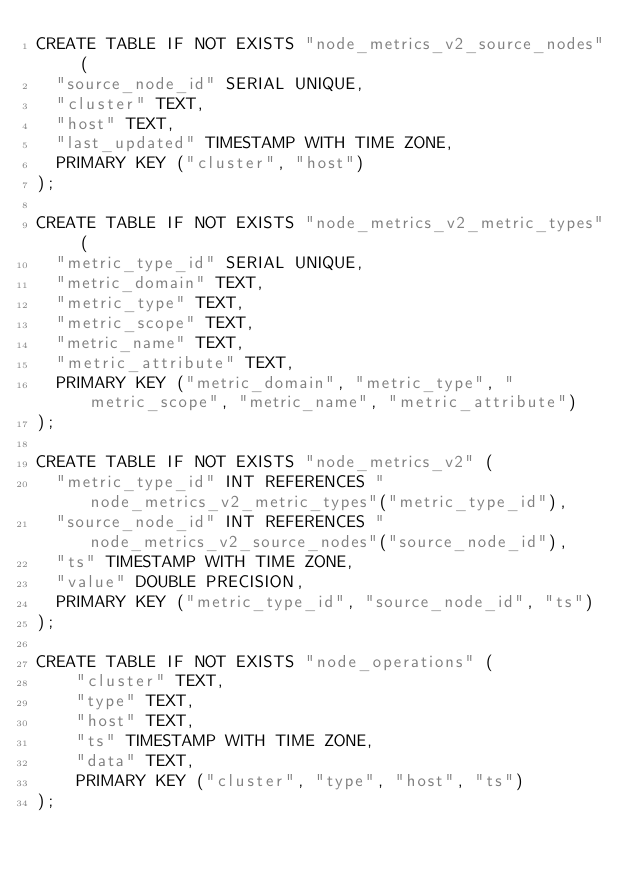Convert code to text. <code><loc_0><loc_0><loc_500><loc_500><_SQL_>CREATE TABLE IF NOT EXISTS "node_metrics_v2_source_nodes" (
  "source_node_id" SERIAL UNIQUE,
  "cluster" TEXT,
  "host" TEXT,
  "last_updated" TIMESTAMP WITH TIME ZONE,
  PRIMARY KEY ("cluster", "host")
);

CREATE TABLE IF NOT EXISTS "node_metrics_v2_metric_types" (
  "metric_type_id" SERIAL UNIQUE,
  "metric_domain" TEXT,
  "metric_type" TEXT,
  "metric_scope" TEXT,
  "metric_name" TEXT,
  "metric_attribute" TEXT,
  PRIMARY KEY ("metric_domain", "metric_type", "metric_scope", "metric_name", "metric_attribute")
);

CREATE TABLE IF NOT EXISTS "node_metrics_v2" (
  "metric_type_id" INT REFERENCES "node_metrics_v2_metric_types"("metric_type_id"),
  "source_node_id" INT REFERENCES "node_metrics_v2_source_nodes"("source_node_id"),
  "ts" TIMESTAMP WITH TIME ZONE,
  "value" DOUBLE PRECISION,
  PRIMARY KEY ("metric_type_id", "source_node_id", "ts")
);

CREATE TABLE IF NOT EXISTS "node_operations" (
    "cluster" TEXT,
    "type" TEXT,
    "host" TEXT,
    "ts" TIMESTAMP WITH TIME ZONE,
    "data" TEXT,
    PRIMARY KEY ("cluster", "type", "host", "ts")
);
</code> 